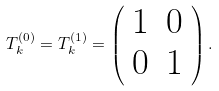<formula> <loc_0><loc_0><loc_500><loc_500>T ^ { ( 0 ) } _ { k } = T ^ { ( 1 ) } _ { k } = \left ( \begin{array} { r r } 1 & 0 \\ 0 & 1 \end{array} \right ) .</formula> 